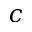<formula> <loc_0><loc_0><loc_500><loc_500>c</formula> 